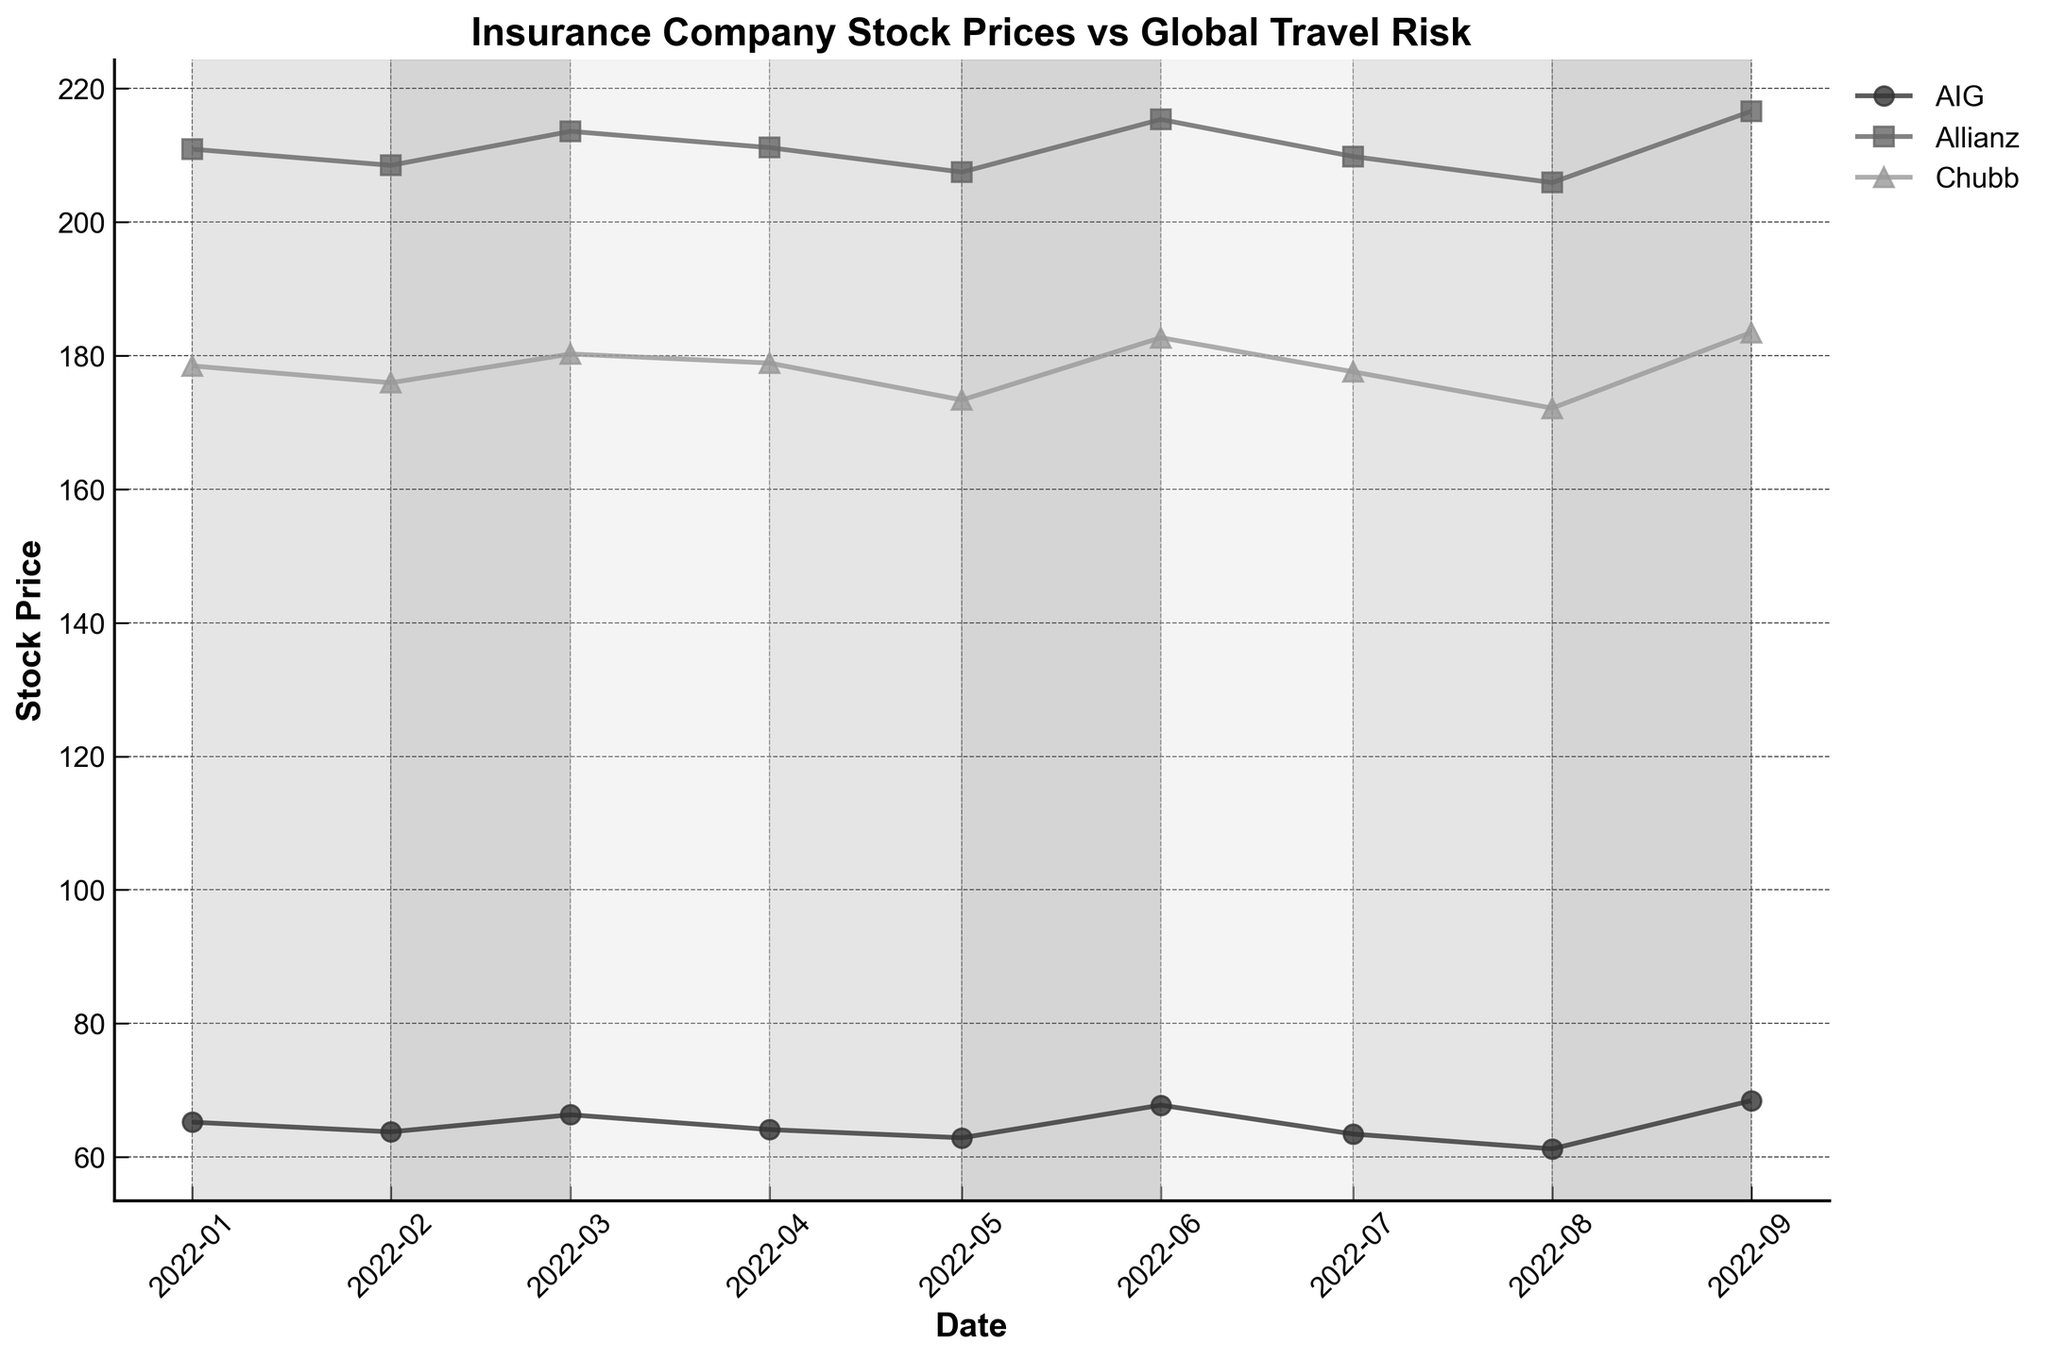What is the title of the plot? The title is displayed at the top of the plot, showing the main topic of the visualization.
Answer: Insurance Company Stock Prices vs Global Travel Risk How many companies' stock prices are plotted? There are distinct lines for each company in the plot. By observing the legend, we can count the number of different companies.
Answer: Three What is the color of the line used for Allianz stock price? By looking at the plot and identifying the line labeled Allianz in the legend, we can observe its color.
Answer: Medium gray Which month shows the highest stock price for AIG? We need to analyze the plot for the line representing AIG to identify the peak point and match it to the corresponding date.
Answer: September 2022 In which periods is the global travel risk level high? The background shading of the plot indicates different risk levels. High-risk periods are shaded in the darkest gray.
Answer: February, May, August Which company has the least fluctuation in stock prices? By examining the lines of each company on the plot, we observe their range of fluctuation. The one with the smallest difference between its highest and lowest values will be the answer.
Answer: Allianz On which dates do the stock prices of all companies decline? We need to look for simultaneous downward trends across all three lines at specific date points.
Answer: February, May, August What is the difference in stock price of Chubb between May and June? Identify the stock price of Chubb in May and June and then calculate the difference (June - May).
Answer: 9.33 How do stock prices of the three companies generally respond to periods of high global travel risk? Observe the overall trend of each company's stock price during the high-risk shaded periods.
Answer: They typically decline During which month did Allianz have its highest recorded stock price, and what was that price? Find the highest point on the line for Allianz and match it to the corresponding month on the x-axis.
Answer: September 2022, 216.56 